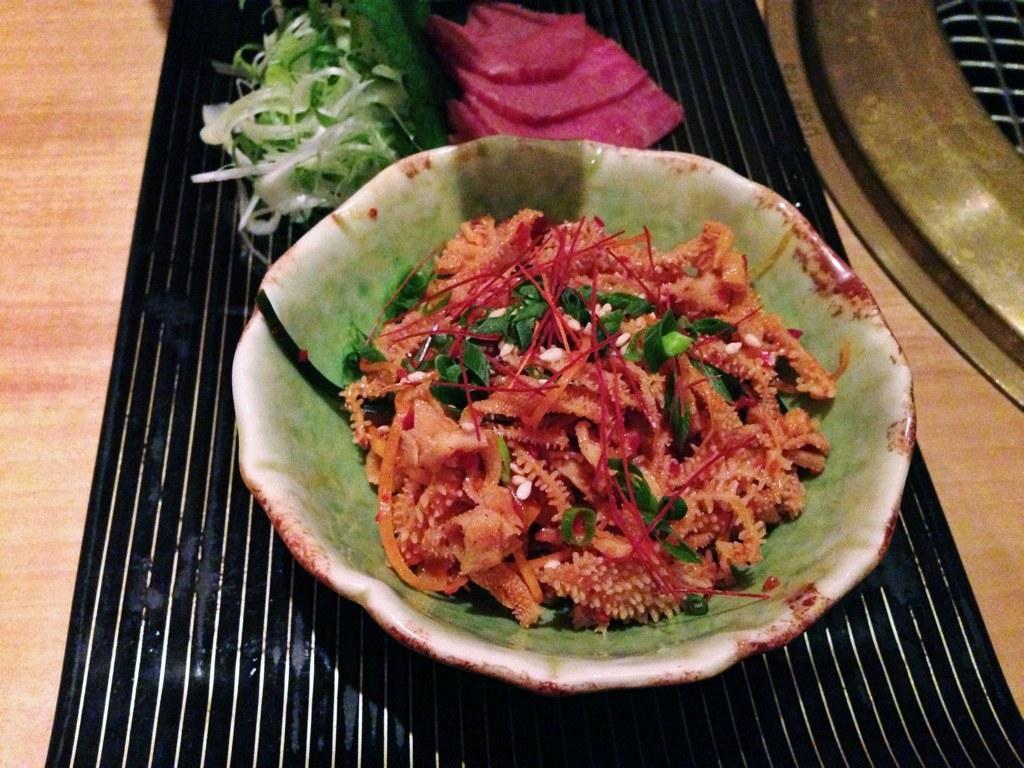Describe this image in one or two sentences. In this image there is a wooden table. In the center there is a placemat. On the placemat there are towels, vegetables and a bowl. There is food in the bowl. 